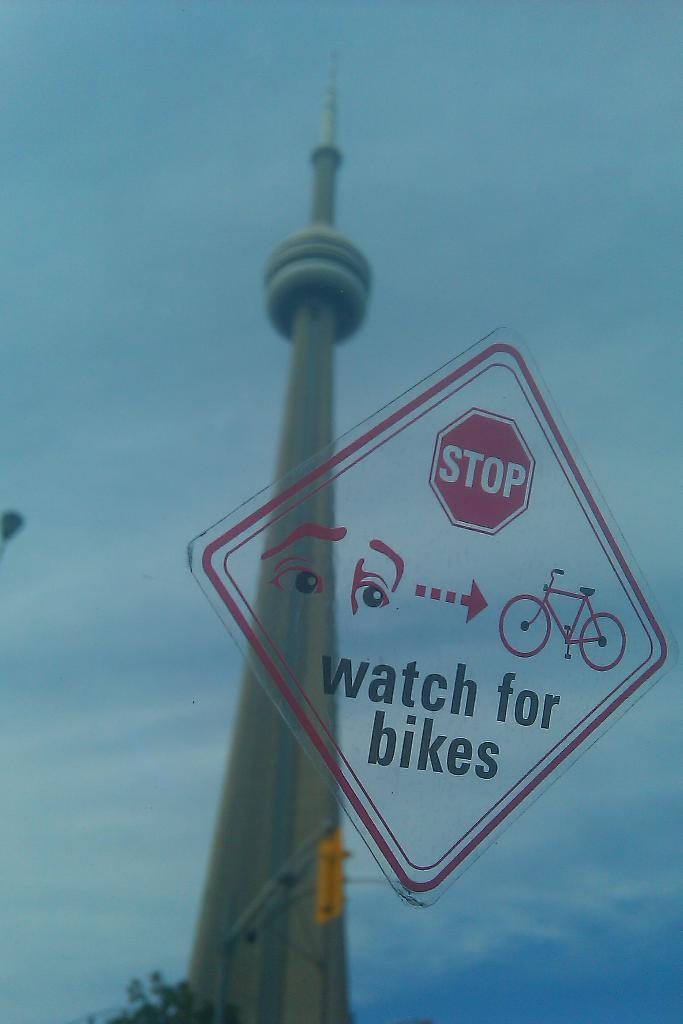<image>
Share a concise interpretation of the image provided. A transluscent stop sign with a bike warning on the bottom with the space needle in the background. 